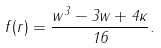<formula> <loc_0><loc_0><loc_500><loc_500>f ( r ) = \frac { w ^ { 3 } - 3 w + 4 \kappa } { 1 6 } .</formula> 